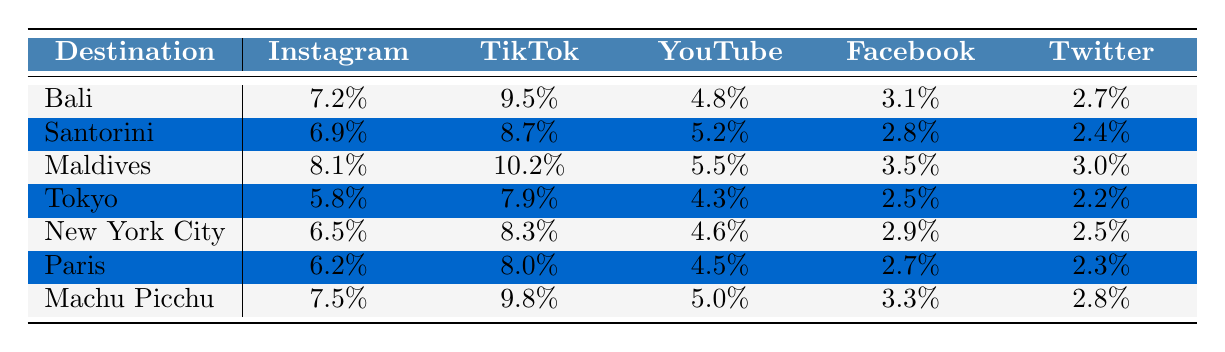What is the engagement rate for Bali on Instagram? The engagement rate for Bali on Instagram is located in the first row and first column of the table, which shows a value of 7.2%.
Answer: 7.2% Which platform has the highest engagement rate for Machu Picchu? The engagement rates for Machu Picchu can be read from its row, where TikTok has the highest engagement rate at 9.8%.
Answer: TikTok What is the average engagement rate across all platforms for Maldives? The engagement rates for Maldives are 8.1%, 10.2%, 5.5%, 3.5%, and 3.0% across the respective platforms. Summing these gives 30.3%, and dividing by 5 yields an average of 6.06%.
Answer: 6.06% Is the engagement rate on Facebook for Santorini higher than that for Tokyo? The engagement rate for Santorini on Facebook is 2.8%, while for Tokyo it is 2.5%. Comparing these shows that Santorini has a higher rate.
Answer: Yes What is the difference in engagement rates between TikTok and YouTube for New York City? The engagement rate on TikTok for New York City is 8.3% and on YouTube it is 4.6%. The difference can be calculated by subtracting 4.6% from 8.3%, which equals 3.7%.
Answer: 3.7% Which destination has the lowest engagement rate on Facebook? From the data, we check all the Facebook engagement rates: 3.1% for Bali, 2.8% for Santorini, 3.5% for Maldives, 2.5% for Tokyo, 2.9% for New York City, 2.7% for Paris, and 3.3% for Machu Picchu. The lowest value is 2.5% for Tokyo.
Answer: Tokyo What is the average engagement rate for Instagram across all destinations? The Instagram engagement rates are 7.2%, 6.9%, 8.1%, 5.8%, 6.5%, 6.2%, and 7.5%. Summing these values gives 49.2%. Dividing this by 7 provides an average of 7.02%.
Answer: 7.02% Is the average likes for posts in Santorini higher than in Paris? The average likes for Santorini is 45,000, while for Paris it is 41,000. Since 45,000 is greater than 41,000, Santorini has higher average likes.
Answer: Yes What is the total average shares for all platforms in Bali? The average shares for Bali across the platforms are 300, 10,000, 1,500, 100, and 50. Adding these together gives a total of 11,950.
Answer: 11,950 Which platform shows a consistent engagement rate trend across all destinations? By analyzing the engagement rates, they show different highs and lows among platforms. However, no platform shows a consistent pattern across all destinations, as the maximums and minimums vary significantly.
Answer: No 